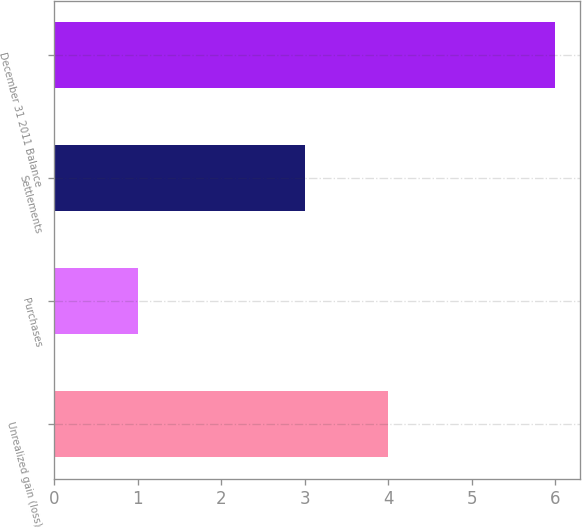<chart> <loc_0><loc_0><loc_500><loc_500><bar_chart><fcel>Unrealized gain (loss)<fcel>Purchases<fcel>Settlements<fcel>December 31 2011 Balance<nl><fcel>4<fcel>1<fcel>3<fcel>6<nl></chart> 